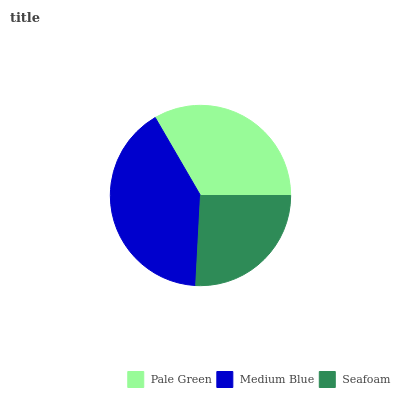Is Seafoam the minimum?
Answer yes or no. Yes. Is Medium Blue the maximum?
Answer yes or no. Yes. Is Medium Blue the minimum?
Answer yes or no. No. Is Seafoam the maximum?
Answer yes or no. No. Is Medium Blue greater than Seafoam?
Answer yes or no. Yes. Is Seafoam less than Medium Blue?
Answer yes or no. Yes. Is Seafoam greater than Medium Blue?
Answer yes or no. No. Is Medium Blue less than Seafoam?
Answer yes or no. No. Is Pale Green the high median?
Answer yes or no. Yes. Is Pale Green the low median?
Answer yes or no. Yes. Is Seafoam the high median?
Answer yes or no. No. Is Medium Blue the low median?
Answer yes or no. No. 